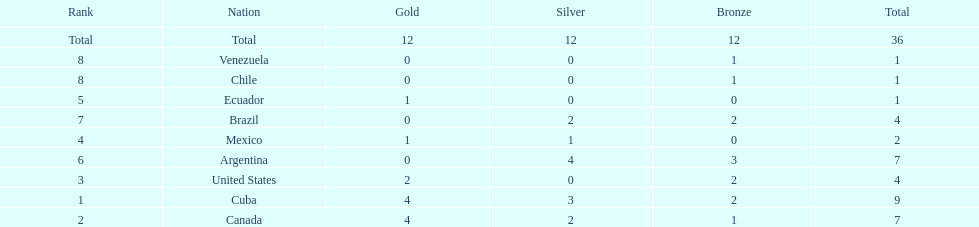How many total medals did argentina win? 7. 